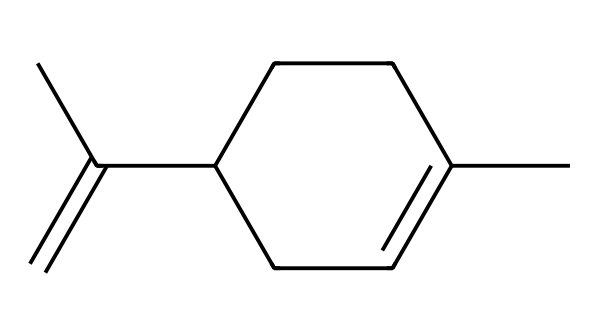how many carbon atoms are in this molecule? The SMILES representation indicates a total of 10 carbon atoms in the structure. By counting the carbon symbols (C) in the SMILES, we verify that there are indeed 10.
Answer: 10 what type of functional group is present in limonene? Limonene primarily contains a cycloalkene functional group indicated by the presence of a double bond in its ring structure. This can be identified in the SMILES, as it features a C=C bond in a cyclic arrangement.
Answer: cycloalkene does limonene have any chiral centers? Analyzing the structure, there are no chiral centers in limonene because none of the carbon atoms are attached to four different substituents. Since the structure shows symmetry due to its cyclic nature, this can be concluded.
Answer: no what is the main characteristic of limonene that contributes to its fragrance? The presence of the aliphatic and double-bonded carbon structure contributes significantly to limonene's citrus fragrance. The specific arrangement of these atoms allows for pleasing volatile compounds that provide the characteristic scent.
Answer: citrus fragrance how many double bonds are in limonene? Looking closely at the structure, there is one double bond evident in the ring part of the cycloalkene. The SMILES notation clearly shows where that double bond is located in the molecule.
Answer: 1 is limonene hydrophobic or hydrophilic? Given its non-polar hydrocarbon structure, limonene is classified as hydrophobic, which means it does not mix well with water and is instead soluble in oils. This classification can be derived from its carbon and hydrogen-rich framework.
Answer: hydrophobic 